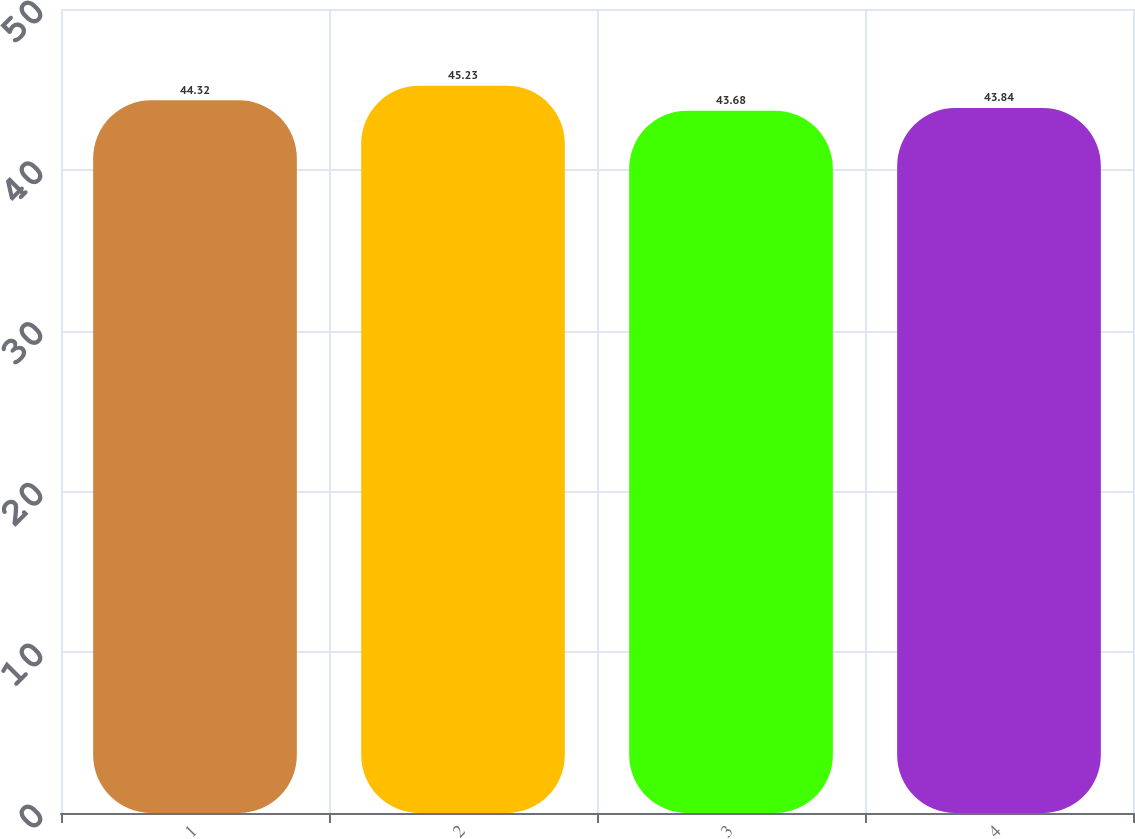Convert chart. <chart><loc_0><loc_0><loc_500><loc_500><bar_chart><fcel>1<fcel>2<fcel>3<fcel>4<nl><fcel>44.32<fcel>45.23<fcel>43.68<fcel>43.84<nl></chart> 